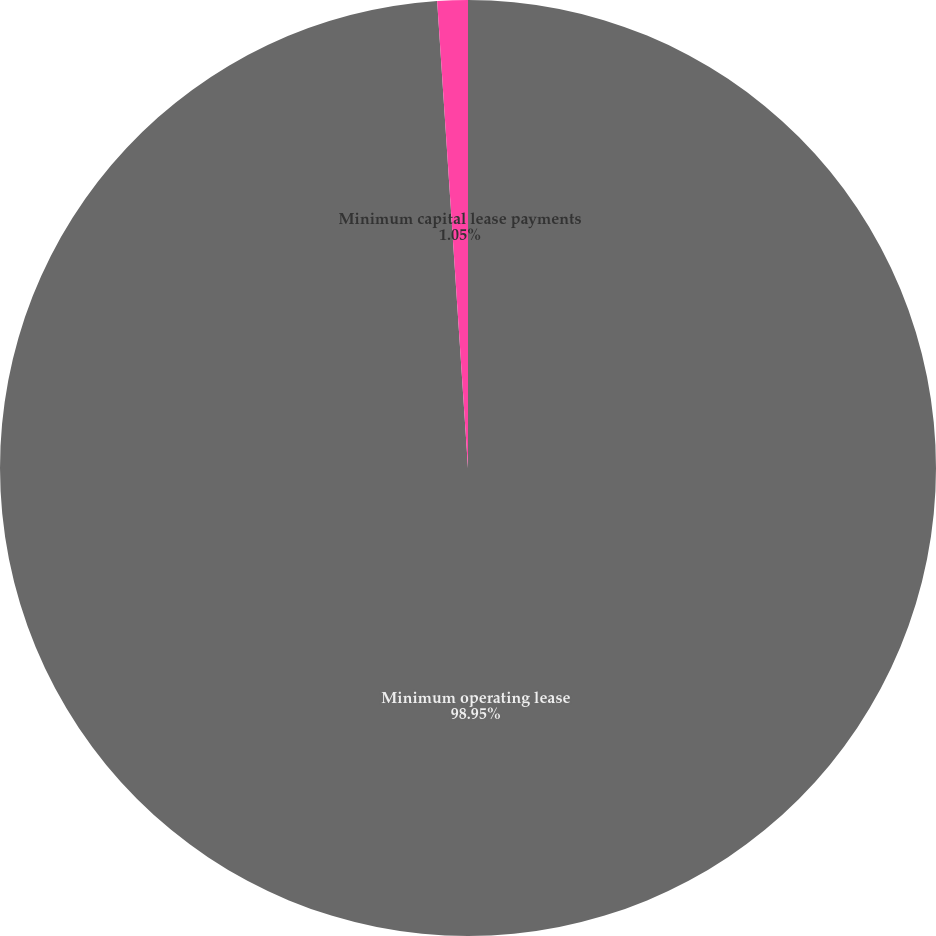Convert chart. <chart><loc_0><loc_0><loc_500><loc_500><pie_chart><fcel>Minimum operating lease<fcel>Minimum capital lease payments<nl><fcel>98.95%<fcel>1.05%<nl></chart> 